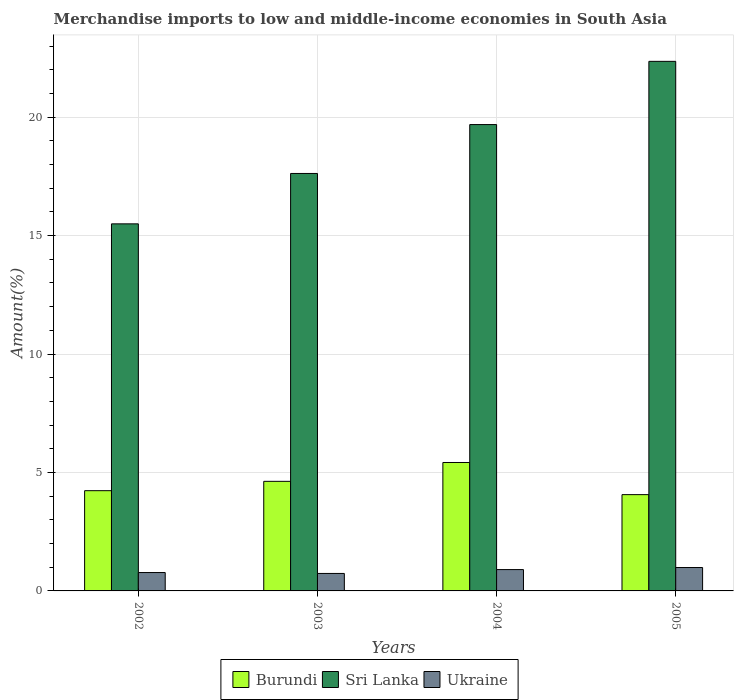How many different coloured bars are there?
Offer a very short reply. 3. Are the number of bars per tick equal to the number of legend labels?
Your response must be concise. Yes. How many bars are there on the 3rd tick from the right?
Ensure brevity in your answer.  3. In how many cases, is the number of bars for a given year not equal to the number of legend labels?
Your answer should be compact. 0. What is the percentage of amount earned from merchandise imports in Sri Lanka in 2002?
Offer a terse response. 15.49. Across all years, what is the maximum percentage of amount earned from merchandise imports in Burundi?
Provide a succinct answer. 5.42. Across all years, what is the minimum percentage of amount earned from merchandise imports in Ukraine?
Provide a succinct answer. 0.74. In which year was the percentage of amount earned from merchandise imports in Burundi maximum?
Your response must be concise. 2004. In which year was the percentage of amount earned from merchandise imports in Burundi minimum?
Your answer should be compact. 2005. What is the total percentage of amount earned from merchandise imports in Burundi in the graph?
Your answer should be very brief. 18.34. What is the difference between the percentage of amount earned from merchandise imports in Sri Lanka in 2003 and that in 2005?
Give a very brief answer. -4.73. What is the difference between the percentage of amount earned from merchandise imports in Sri Lanka in 2005 and the percentage of amount earned from merchandise imports in Burundi in 2003?
Your answer should be very brief. 17.73. What is the average percentage of amount earned from merchandise imports in Sri Lanka per year?
Offer a terse response. 18.79. In the year 2004, what is the difference between the percentage of amount earned from merchandise imports in Sri Lanka and percentage of amount earned from merchandise imports in Burundi?
Your answer should be very brief. 14.26. What is the ratio of the percentage of amount earned from merchandise imports in Sri Lanka in 2002 to that in 2005?
Keep it short and to the point. 0.69. Is the difference between the percentage of amount earned from merchandise imports in Sri Lanka in 2002 and 2005 greater than the difference between the percentage of amount earned from merchandise imports in Burundi in 2002 and 2005?
Provide a short and direct response. No. What is the difference between the highest and the second highest percentage of amount earned from merchandise imports in Sri Lanka?
Your answer should be very brief. 2.67. What is the difference between the highest and the lowest percentage of amount earned from merchandise imports in Ukraine?
Ensure brevity in your answer.  0.25. What does the 2nd bar from the left in 2002 represents?
Give a very brief answer. Sri Lanka. What does the 3rd bar from the right in 2005 represents?
Provide a succinct answer. Burundi. How many bars are there?
Your response must be concise. 12. Are the values on the major ticks of Y-axis written in scientific E-notation?
Your answer should be compact. No. Where does the legend appear in the graph?
Keep it short and to the point. Bottom center. How are the legend labels stacked?
Offer a terse response. Horizontal. What is the title of the graph?
Your answer should be compact. Merchandise imports to low and middle-income economies in South Asia. What is the label or title of the Y-axis?
Ensure brevity in your answer.  Amount(%). What is the Amount(%) in Burundi in 2002?
Your answer should be compact. 4.23. What is the Amount(%) of Sri Lanka in 2002?
Your answer should be compact. 15.49. What is the Amount(%) in Ukraine in 2002?
Offer a terse response. 0.78. What is the Amount(%) of Burundi in 2003?
Offer a terse response. 4.63. What is the Amount(%) in Sri Lanka in 2003?
Keep it short and to the point. 17.62. What is the Amount(%) in Ukraine in 2003?
Your answer should be very brief. 0.74. What is the Amount(%) of Burundi in 2004?
Ensure brevity in your answer.  5.42. What is the Amount(%) of Sri Lanka in 2004?
Offer a terse response. 19.69. What is the Amount(%) in Ukraine in 2004?
Offer a terse response. 0.9. What is the Amount(%) in Burundi in 2005?
Provide a succinct answer. 4.06. What is the Amount(%) in Sri Lanka in 2005?
Give a very brief answer. 22.35. What is the Amount(%) of Ukraine in 2005?
Keep it short and to the point. 0.99. Across all years, what is the maximum Amount(%) in Burundi?
Your response must be concise. 5.42. Across all years, what is the maximum Amount(%) in Sri Lanka?
Your answer should be very brief. 22.35. Across all years, what is the maximum Amount(%) in Ukraine?
Offer a terse response. 0.99. Across all years, what is the minimum Amount(%) in Burundi?
Your answer should be very brief. 4.06. Across all years, what is the minimum Amount(%) in Sri Lanka?
Offer a very short reply. 15.49. Across all years, what is the minimum Amount(%) of Ukraine?
Provide a short and direct response. 0.74. What is the total Amount(%) in Burundi in the graph?
Keep it short and to the point. 18.34. What is the total Amount(%) of Sri Lanka in the graph?
Your answer should be compact. 75.16. What is the total Amount(%) of Ukraine in the graph?
Your answer should be compact. 3.4. What is the difference between the Amount(%) of Burundi in 2002 and that in 2003?
Make the answer very short. -0.39. What is the difference between the Amount(%) in Sri Lanka in 2002 and that in 2003?
Offer a very short reply. -2.13. What is the difference between the Amount(%) of Ukraine in 2002 and that in 2003?
Ensure brevity in your answer.  0.04. What is the difference between the Amount(%) in Burundi in 2002 and that in 2004?
Keep it short and to the point. -1.19. What is the difference between the Amount(%) in Sri Lanka in 2002 and that in 2004?
Keep it short and to the point. -4.19. What is the difference between the Amount(%) in Ukraine in 2002 and that in 2004?
Provide a short and direct response. -0.12. What is the difference between the Amount(%) in Burundi in 2002 and that in 2005?
Keep it short and to the point. 0.17. What is the difference between the Amount(%) in Sri Lanka in 2002 and that in 2005?
Your answer should be compact. -6.86. What is the difference between the Amount(%) in Ukraine in 2002 and that in 2005?
Your answer should be compact. -0.21. What is the difference between the Amount(%) in Burundi in 2003 and that in 2004?
Offer a very short reply. -0.8. What is the difference between the Amount(%) of Sri Lanka in 2003 and that in 2004?
Keep it short and to the point. -2.06. What is the difference between the Amount(%) in Ukraine in 2003 and that in 2004?
Your answer should be very brief. -0.16. What is the difference between the Amount(%) of Burundi in 2003 and that in 2005?
Offer a terse response. 0.56. What is the difference between the Amount(%) in Sri Lanka in 2003 and that in 2005?
Ensure brevity in your answer.  -4.73. What is the difference between the Amount(%) of Ukraine in 2003 and that in 2005?
Your answer should be compact. -0.25. What is the difference between the Amount(%) of Burundi in 2004 and that in 2005?
Offer a very short reply. 1.36. What is the difference between the Amount(%) of Sri Lanka in 2004 and that in 2005?
Provide a short and direct response. -2.67. What is the difference between the Amount(%) of Ukraine in 2004 and that in 2005?
Keep it short and to the point. -0.09. What is the difference between the Amount(%) of Burundi in 2002 and the Amount(%) of Sri Lanka in 2003?
Provide a succinct answer. -13.39. What is the difference between the Amount(%) of Burundi in 2002 and the Amount(%) of Ukraine in 2003?
Ensure brevity in your answer.  3.49. What is the difference between the Amount(%) of Sri Lanka in 2002 and the Amount(%) of Ukraine in 2003?
Your response must be concise. 14.76. What is the difference between the Amount(%) of Burundi in 2002 and the Amount(%) of Sri Lanka in 2004?
Provide a succinct answer. -15.45. What is the difference between the Amount(%) of Burundi in 2002 and the Amount(%) of Ukraine in 2004?
Give a very brief answer. 3.33. What is the difference between the Amount(%) of Sri Lanka in 2002 and the Amount(%) of Ukraine in 2004?
Provide a short and direct response. 14.59. What is the difference between the Amount(%) of Burundi in 2002 and the Amount(%) of Sri Lanka in 2005?
Provide a succinct answer. -18.12. What is the difference between the Amount(%) of Burundi in 2002 and the Amount(%) of Ukraine in 2005?
Give a very brief answer. 3.24. What is the difference between the Amount(%) of Sri Lanka in 2002 and the Amount(%) of Ukraine in 2005?
Offer a very short reply. 14.51. What is the difference between the Amount(%) of Burundi in 2003 and the Amount(%) of Sri Lanka in 2004?
Offer a very short reply. -15.06. What is the difference between the Amount(%) of Burundi in 2003 and the Amount(%) of Ukraine in 2004?
Offer a very short reply. 3.72. What is the difference between the Amount(%) in Sri Lanka in 2003 and the Amount(%) in Ukraine in 2004?
Keep it short and to the point. 16.72. What is the difference between the Amount(%) of Burundi in 2003 and the Amount(%) of Sri Lanka in 2005?
Your answer should be compact. -17.73. What is the difference between the Amount(%) in Burundi in 2003 and the Amount(%) in Ukraine in 2005?
Ensure brevity in your answer.  3.64. What is the difference between the Amount(%) of Sri Lanka in 2003 and the Amount(%) of Ukraine in 2005?
Make the answer very short. 16.63. What is the difference between the Amount(%) in Burundi in 2004 and the Amount(%) in Sri Lanka in 2005?
Provide a short and direct response. -16.93. What is the difference between the Amount(%) of Burundi in 2004 and the Amount(%) of Ukraine in 2005?
Your answer should be compact. 4.43. What is the difference between the Amount(%) of Sri Lanka in 2004 and the Amount(%) of Ukraine in 2005?
Keep it short and to the point. 18.7. What is the average Amount(%) in Burundi per year?
Provide a short and direct response. 4.59. What is the average Amount(%) of Sri Lanka per year?
Your answer should be very brief. 18.79. What is the average Amount(%) in Ukraine per year?
Offer a very short reply. 0.85. In the year 2002, what is the difference between the Amount(%) in Burundi and Amount(%) in Sri Lanka?
Provide a short and direct response. -11.26. In the year 2002, what is the difference between the Amount(%) of Burundi and Amount(%) of Ukraine?
Make the answer very short. 3.46. In the year 2002, what is the difference between the Amount(%) in Sri Lanka and Amount(%) in Ukraine?
Your answer should be very brief. 14.72. In the year 2003, what is the difference between the Amount(%) in Burundi and Amount(%) in Sri Lanka?
Offer a terse response. -13. In the year 2003, what is the difference between the Amount(%) in Burundi and Amount(%) in Ukraine?
Your response must be concise. 3.89. In the year 2003, what is the difference between the Amount(%) in Sri Lanka and Amount(%) in Ukraine?
Ensure brevity in your answer.  16.88. In the year 2004, what is the difference between the Amount(%) in Burundi and Amount(%) in Sri Lanka?
Provide a succinct answer. -14.26. In the year 2004, what is the difference between the Amount(%) of Burundi and Amount(%) of Ukraine?
Your answer should be compact. 4.52. In the year 2004, what is the difference between the Amount(%) of Sri Lanka and Amount(%) of Ukraine?
Provide a short and direct response. 18.78. In the year 2005, what is the difference between the Amount(%) in Burundi and Amount(%) in Sri Lanka?
Offer a very short reply. -18.29. In the year 2005, what is the difference between the Amount(%) of Burundi and Amount(%) of Ukraine?
Your answer should be very brief. 3.08. In the year 2005, what is the difference between the Amount(%) of Sri Lanka and Amount(%) of Ukraine?
Offer a terse response. 21.37. What is the ratio of the Amount(%) in Burundi in 2002 to that in 2003?
Offer a terse response. 0.91. What is the ratio of the Amount(%) in Sri Lanka in 2002 to that in 2003?
Ensure brevity in your answer.  0.88. What is the ratio of the Amount(%) of Ukraine in 2002 to that in 2003?
Your answer should be very brief. 1.05. What is the ratio of the Amount(%) in Burundi in 2002 to that in 2004?
Offer a very short reply. 0.78. What is the ratio of the Amount(%) of Sri Lanka in 2002 to that in 2004?
Ensure brevity in your answer.  0.79. What is the ratio of the Amount(%) of Ukraine in 2002 to that in 2004?
Ensure brevity in your answer.  0.86. What is the ratio of the Amount(%) of Burundi in 2002 to that in 2005?
Offer a very short reply. 1.04. What is the ratio of the Amount(%) in Sri Lanka in 2002 to that in 2005?
Give a very brief answer. 0.69. What is the ratio of the Amount(%) in Ukraine in 2002 to that in 2005?
Offer a terse response. 0.79. What is the ratio of the Amount(%) in Burundi in 2003 to that in 2004?
Make the answer very short. 0.85. What is the ratio of the Amount(%) in Sri Lanka in 2003 to that in 2004?
Give a very brief answer. 0.9. What is the ratio of the Amount(%) in Ukraine in 2003 to that in 2004?
Your response must be concise. 0.82. What is the ratio of the Amount(%) in Burundi in 2003 to that in 2005?
Your answer should be very brief. 1.14. What is the ratio of the Amount(%) in Sri Lanka in 2003 to that in 2005?
Keep it short and to the point. 0.79. What is the ratio of the Amount(%) in Ukraine in 2003 to that in 2005?
Provide a short and direct response. 0.75. What is the ratio of the Amount(%) of Burundi in 2004 to that in 2005?
Ensure brevity in your answer.  1.33. What is the ratio of the Amount(%) of Sri Lanka in 2004 to that in 2005?
Provide a short and direct response. 0.88. What is the ratio of the Amount(%) of Ukraine in 2004 to that in 2005?
Keep it short and to the point. 0.91. What is the difference between the highest and the second highest Amount(%) in Burundi?
Keep it short and to the point. 0.8. What is the difference between the highest and the second highest Amount(%) of Sri Lanka?
Provide a short and direct response. 2.67. What is the difference between the highest and the second highest Amount(%) in Ukraine?
Ensure brevity in your answer.  0.09. What is the difference between the highest and the lowest Amount(%) of Burundi?
Provide a succinct answer. 1.36. What is the difference between the highest and the lowest Amount(%) of Sri Lanka?
Give a very brief answer. 6.86. What is the difference between the highest and the lowest Amount(%) in Ukraine?
Provide a succinct answer. 0.25. 